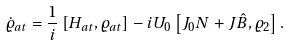<formula> <loc_0><loc_0><loc_500><loc_500>\dot { \varrho } _ { a t } = \frac { 1 } { i } \left [ H _ { a t } , \varrho _ { a t } \right ] - i U _ { 0 } \left [ J _ { 0 } N + J \hat { B } , \varrho _ { 2 } \right ] .</formula> 